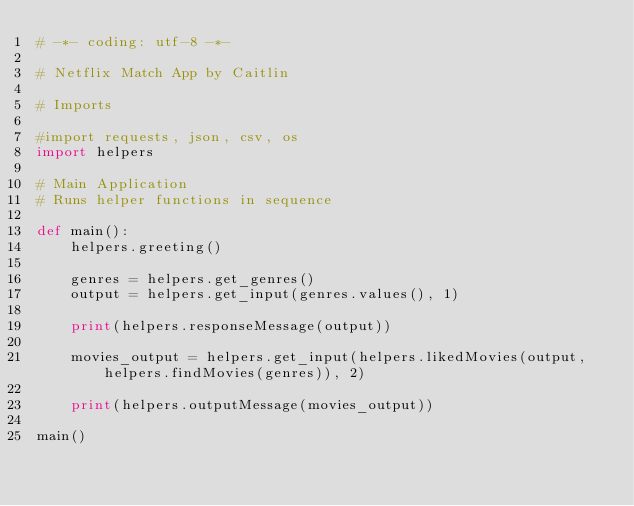<code> <loc_0><loc_0><loc_500><loc_500><_Python_># -*- coding: utf-8 -*-

# Netflix Match App by Caitlin

# Imports

#import requests, json, csv, os
import helpers

# Main Application
# Runs helper functions in sequence

def main():
    helpers.greeting()

    genres = helpers.get_genres()
    output = helpers.get_input(genres.values(), 1)

    print(helpers.responseMessage(output))

    movies_output = helpers.get_input(helpers.likedMovies(output, helpers.findMovies(genres)), 2)

    print(helpers.outputMessage(movies_output))

main()</code> 